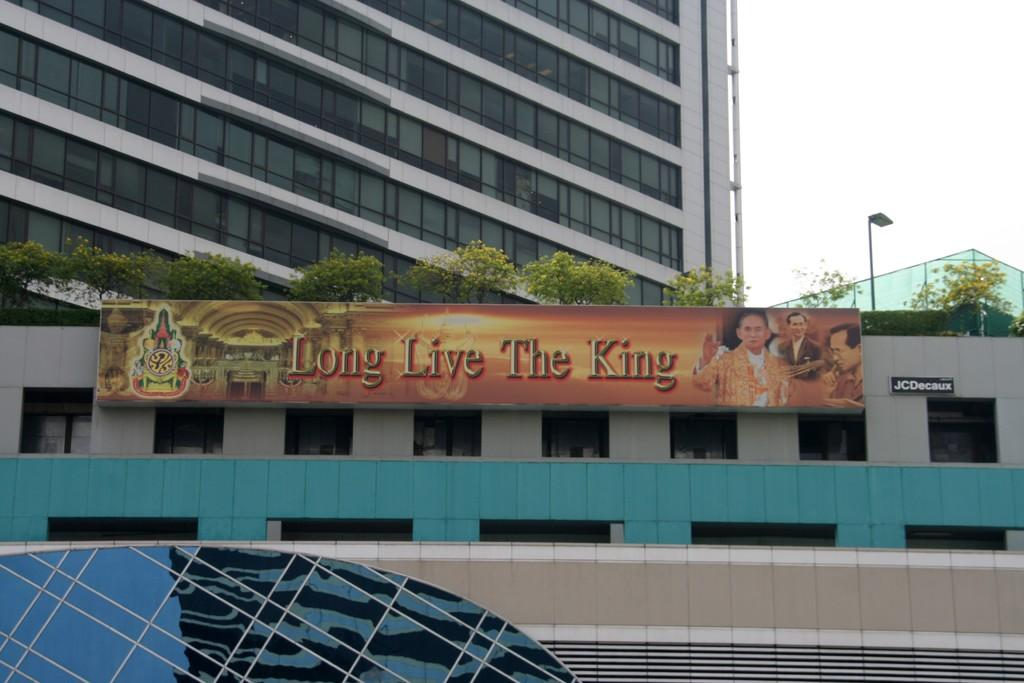What type of structures are visible in the image? There are buildings with windows in the image. What additional object can be seen in the image? There is a banner in the image. What type of vegetation is present in the image? There are trees in the image. What other object can be seen in the image? There is a pole in the image. What can be seen in the background of the image? The sky is visible in the background of the image. What type of bedroom is visible in the image? There is no bedroom present in the image. Can you describe the flight path of the airplane in the image? There is no airplane present in the image. 